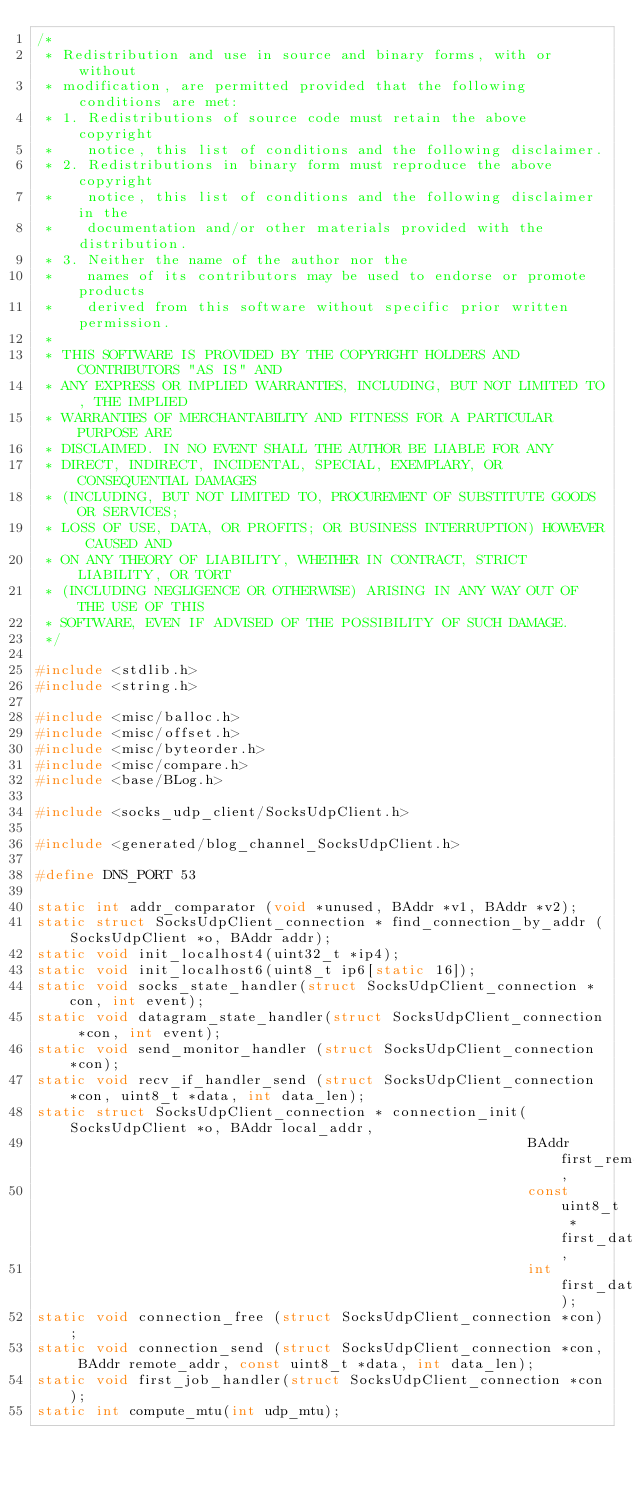<code> <loc_0><loc_0><loc_500><loc_500><_C_>/*
 * Redistribution and use in source and binary forms, with or without
 * modification, are permitted provided that the following conditions are met:
 * 1. Redistributions of source code must retain the above copyright
 *    notice, this list of conditions and the following disclaimer.
 * 2. Redistributions in binary form must reproduce the above copyright
 *    notice, this list of conditions and the following disclaimer in the
 *    documentation and/or other materials provided with the distribution.
 * 3. Neither the name of the author nor the
 *    names of its contributors may be used to endorse or promote products
 *    derived from this software without specific prior written permission.
 * 
 * THIS SOFTWARE IS PROVIDED BY THE COPYRIGHT HOLDERS AND CONTRIBUTORS "AS IS" AND
 * ANY EXPRESS OR IMPLIED WARRANTIES, INCLUDING, BUT NOT LIMITED TO, THE IMPLIED
 * WARRANTIES OF MERCHANTABILITY AND FITNESS FOR A PARTICULAR PURPOSE ARE
 * DISCLAIMED. IN NO EVENT SHALL THE AUTHOR BE LIABLE FOR ANY
 * DIRECT, INDIRECT, INCIDENTAL, SPECIAL, EXEMPLARY, OR CONSEQUENTIAL DAMAGES
 * (INCLUDING, BUT NOT LIMITED TO, PROCUREMENT OF SUBSTITUTE GOODS OR SERVICES;
 * LOSS OF USE, DATA, OR PROFITS; OR BUSINESS INTERRUPTION) HOWEVER CAUSED AND
 * ON ANY THEORY OF LIABILITY, WHETHER IN CONTRACT, STRICT LIABILITY, OR TORT
 * (INCLUDING NEGLIGENCE OR OTHERWISE) ARISING IN ANY WAY OUT OF THE USE OF THIS
 * SOFTWARE, EVEN IF ADVISED OF THE POSSIBILITY OF SUCH DAMAGE.
 */

#include <stdlib.h>
#include <string.h>

#include <misc/balloc.h>
#include <misc/offset.h>
#include <misc/byteorder.h>
#include <misc/compare.h>
#include <base/BLog.h>

#include <socks_udp_client/SocksUdpClient.h>

#include <generated/blog_channel_SocksUdpClient.h>

#define DNS_PORT 53

static int addr_comparator (void *unused, BAddr *v1, BAddr *v2);
static struct SocksUdpClient_connection * find_connection_by_addr (SocksUdpClient *o, BAddr addr);
static void init_localhost4(uint32_t *ip4);
static void init_localhost6(uint8_t ip6[static 16]);
static void socks_state_handler(struct SocksUdpClient_connection *con, int event);
static void datagram_state_handler(struct SocksUdpClient_connection *con, int event);
static void send_monitor_handler (struct SocksUdpClient_connection *con);
static void recv_if_handler_send (struct SocksUdpClient_connection *con, uint8_t *data, int data_len);
static struct SocksUdpClient_connection * connection_init(SocksUdpClient *o, BAddr local_addr,
                                                          BAddr first_remote_addr,
                                                          const uint8_t *first_data,
                                                          int first_data_len);
static void connection_free (struct SocksUdpClient_connection *con);
static void connection_send (struct SocksUdpClient_connection *con, BAddr remote_addr, const uint8_t *data, int data_len);
static void first_job_handler(struct SocksUdpClient_connection *con);
static int compute_mtu(int udp_mtu);</code> 